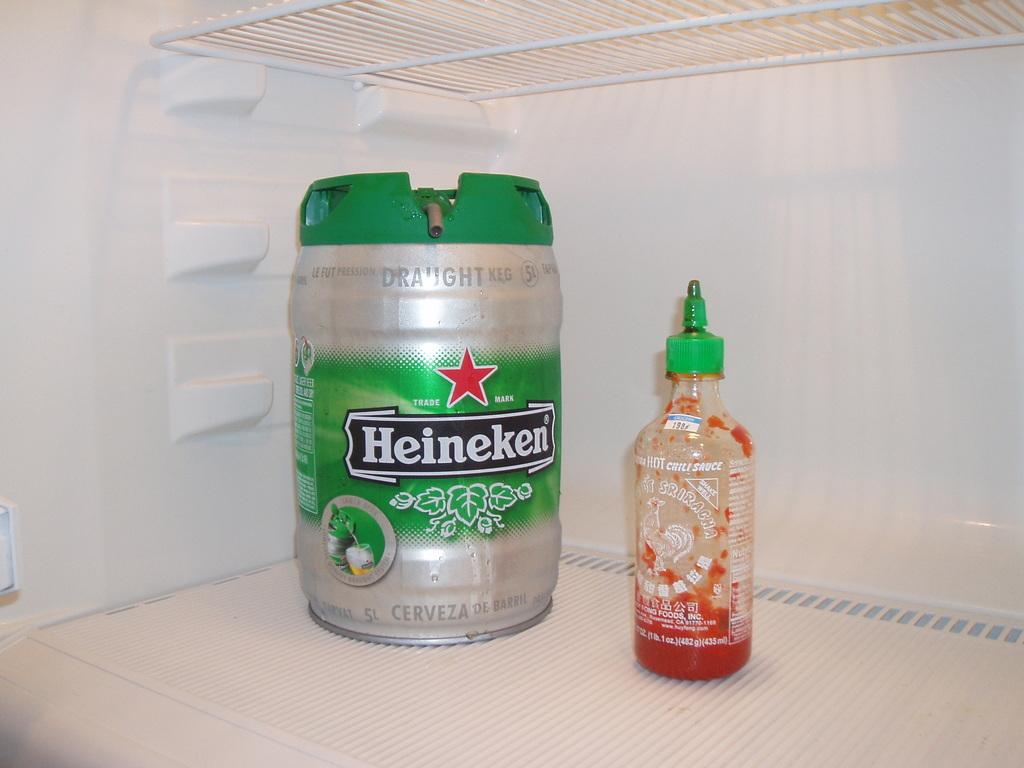<image>
Give a short and clear explanation of the subsequent image. Large Heineken jug next to an empty bottle of siraccha. 